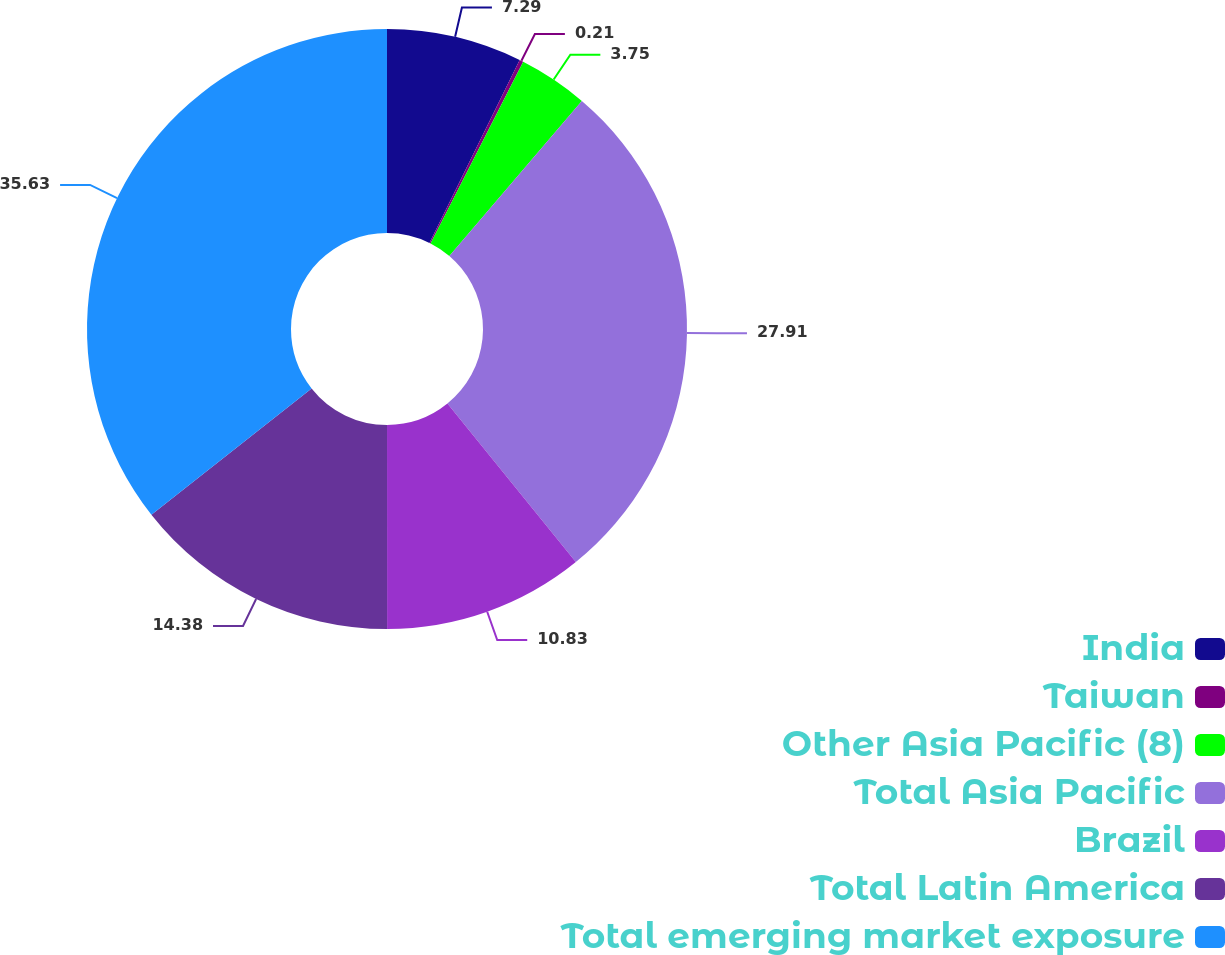Convert chart. <chart><loc_0><loc_0><loc_500><loc_500><pie_chart><fcel>India<fcel>Taiwan<fcel>Other Asia Pacific (8)<fcel>Total Asia Pacific<fcel>Brazil<fcel>Total Latin America<fcel>Total emerging market exposure<nl><fcel>7.29%<fcel>0.21%<fcel>3.75%<fcel>27.91%<fcel>10.83%<fcel>14.38%<fcel>35.62%<nl></chart> 